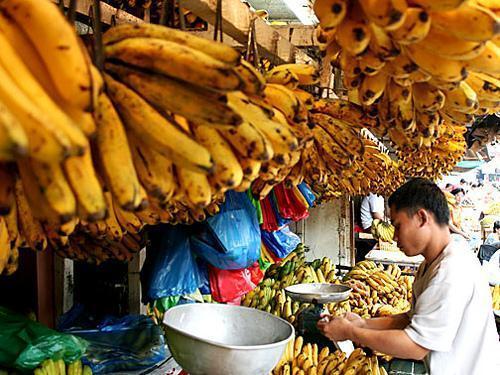How many bananas are there?
Give a very brief answer. 7. 